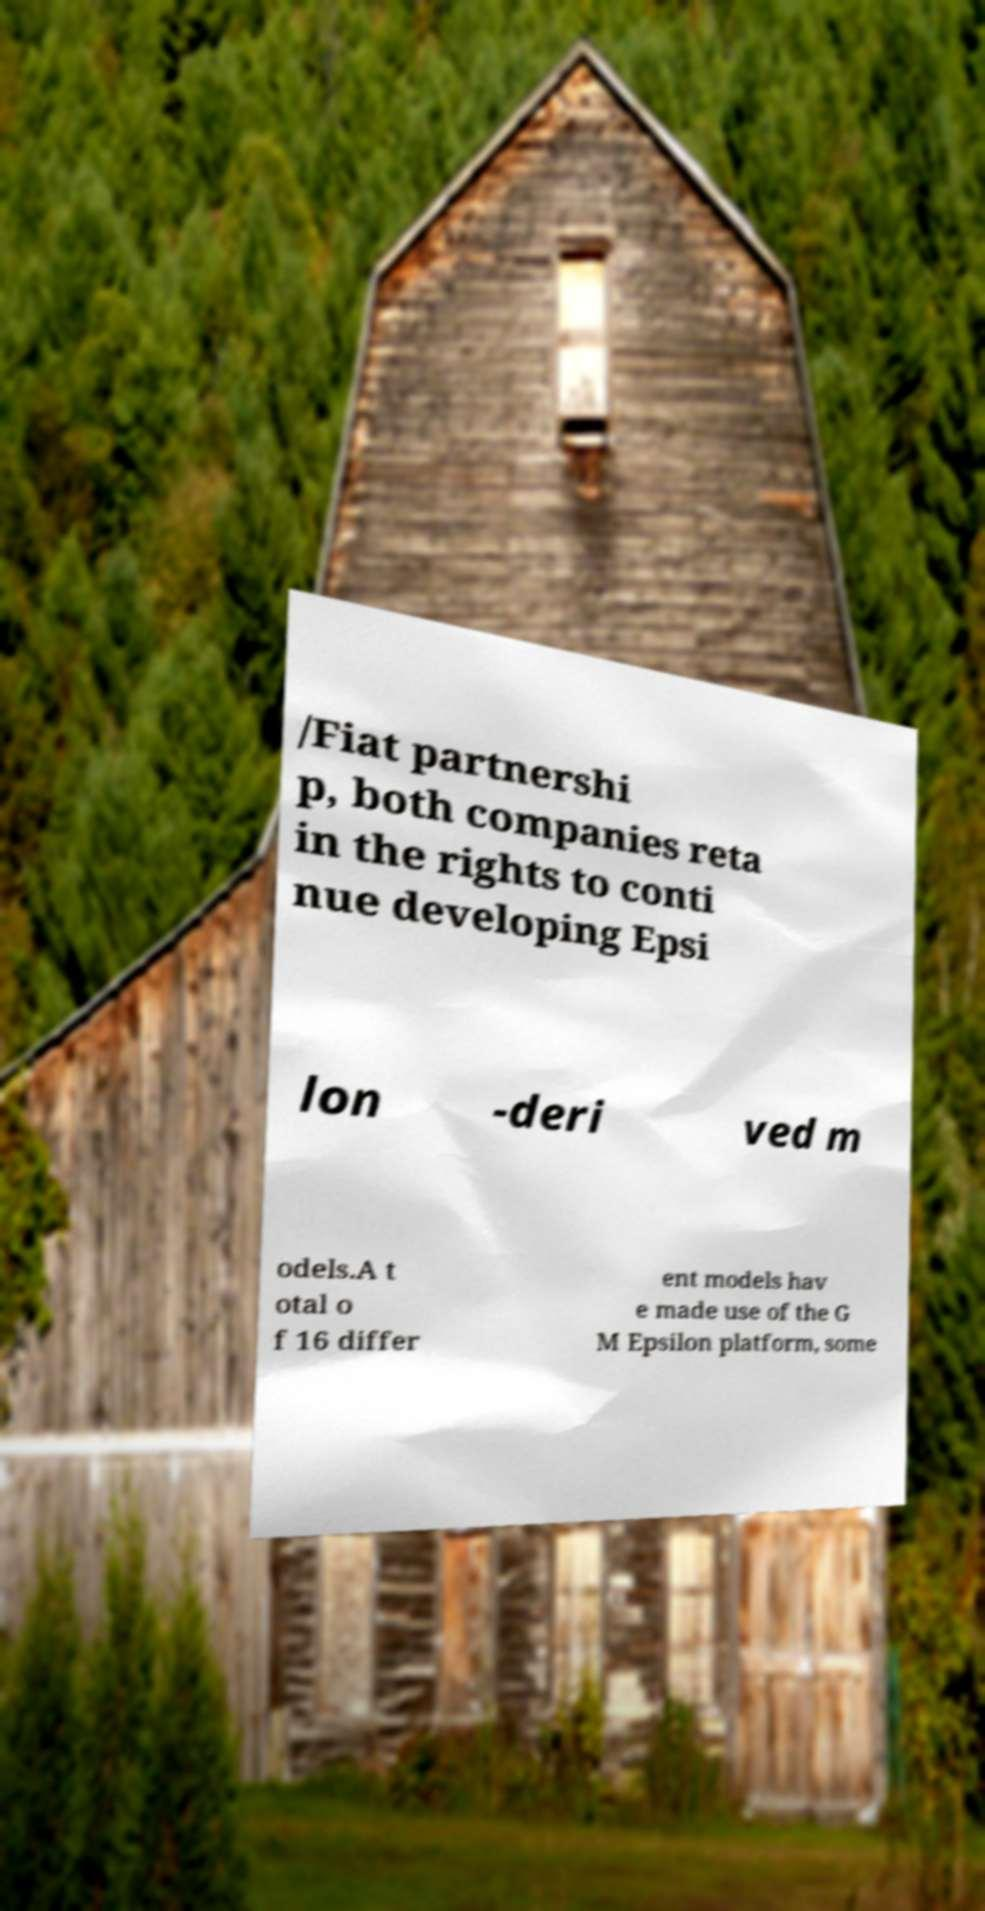Can you accurately transcribe the text from the provided image for me? /Fiat partnershi p, both companies reta in the rights to conti nue developing Epsi lon -deri ved m odels.A t otal o f 16 differ ent models hav e made use of the G M Epsilon platform, some 